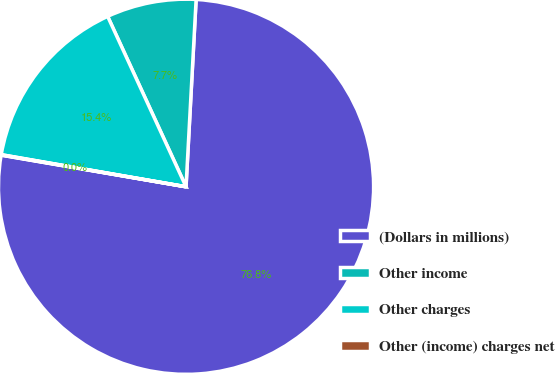Convert chart to OTSL. <chart><loc_0><loc_0><loc_500><loc_500><pie_chart><fcel>(Dollars in millions)<fcel>Other income<fcel>Other charges<fcel>Other (income) charges net<nl><fcel>76.84%<fcel>7.72%<fcel>15.4%<fcel>0.04%<nl></chart> 